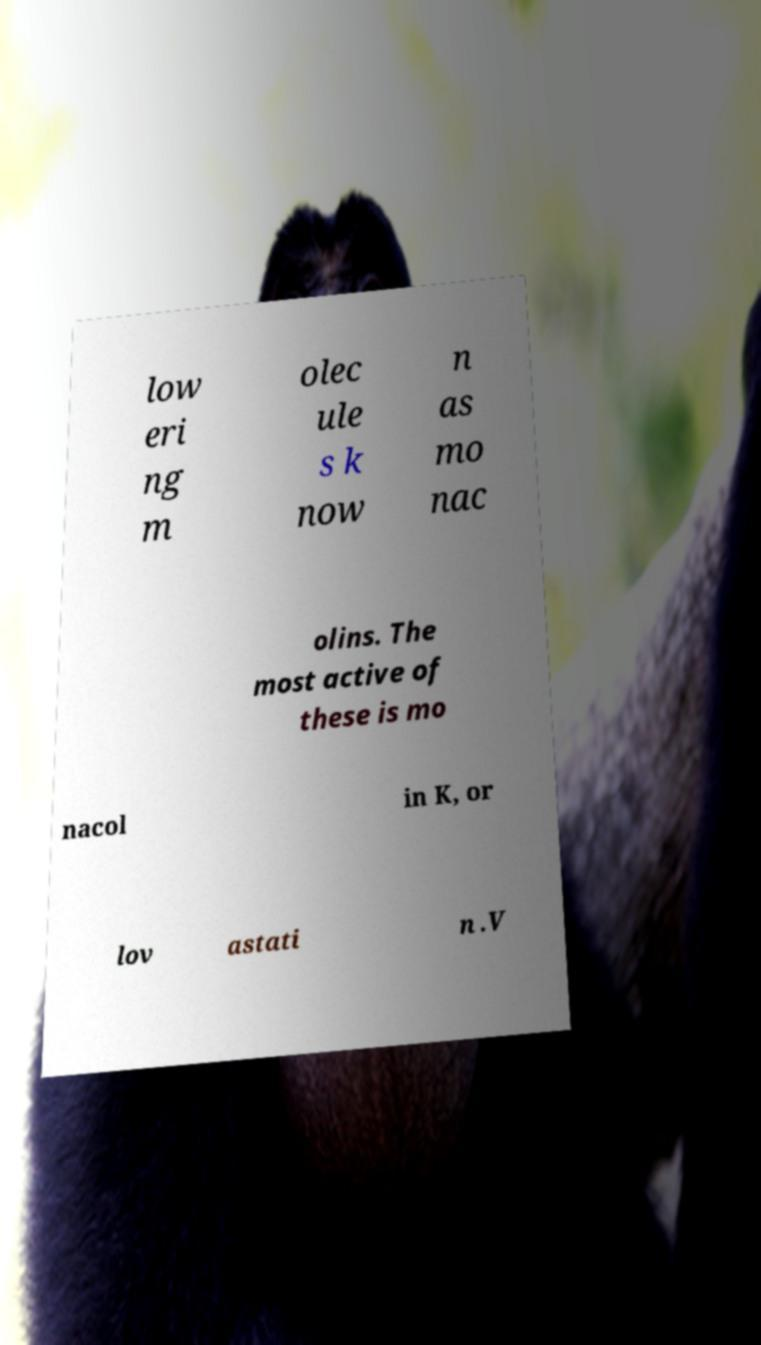Please read and relay the text visible in this image. What does it say? low eri ng m olec ule s k now n as mo nac olins. The most active of these is mo nacol in K, or lov astati n .V 